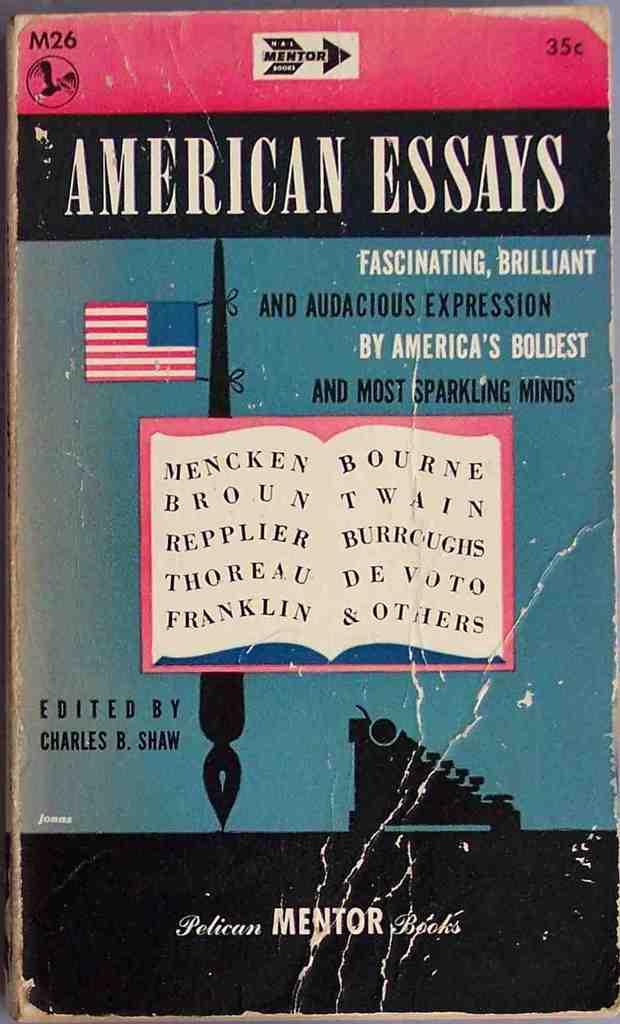<image>
Summarize the visual content of the image. A red, black and blue book cover titled American Essays. 